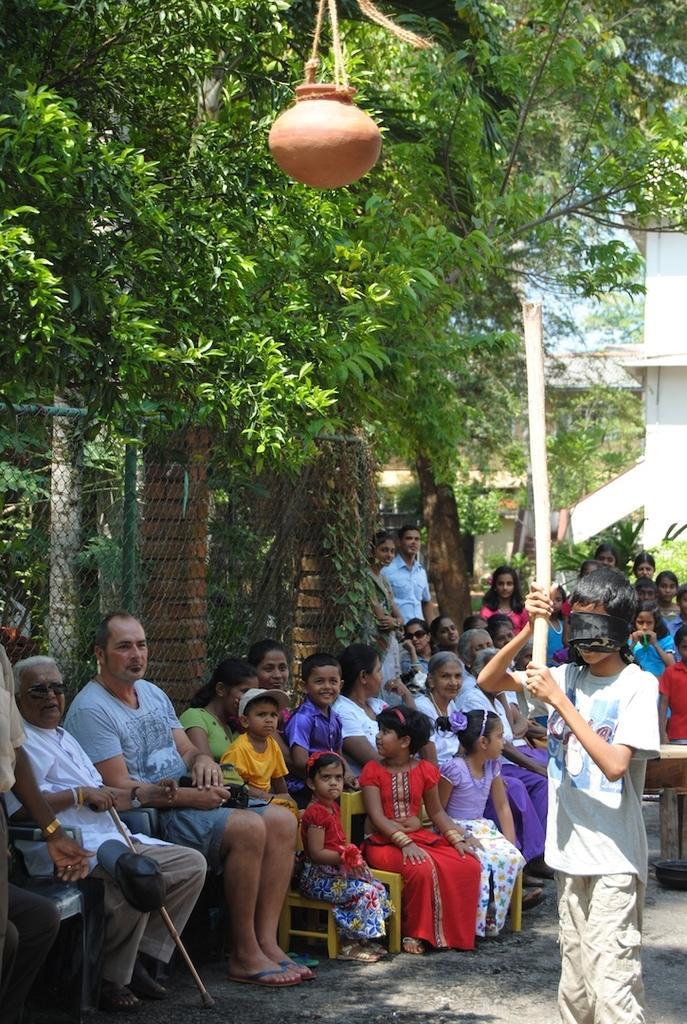Describe this image in one or two sentences. In this image we can see men, women and children are sitting. Behind them, fencing, buildings and trees are there. One boy is standing on the right side of the image. He is wearing white t-shirt, track and holding wooden bamboo in his hands. We can see a pot at the top of the image. 